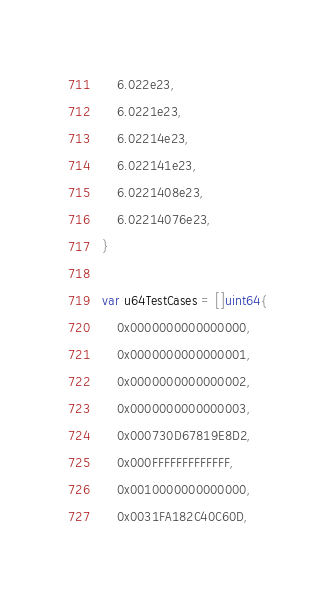<code> <loc_0><loc_0><loc_500><loc_500><_Go_>	6.022e23,
	6.0221e23,
	6.02214e23,
	6.022141e23,
	6.0221408e23,
	6.02214076e23,
}

var u64TestCases = []uint64{
	0x0000000000000000,
	0x0000000000000001,
	0x0000000000000002,
	0x0000000000000003,
	0x000730D67819E8D2,
	0x000FFFFFFFFFFFFF,
	0x0010000000000000,
	0x0031FA182C40C60D,</code> 